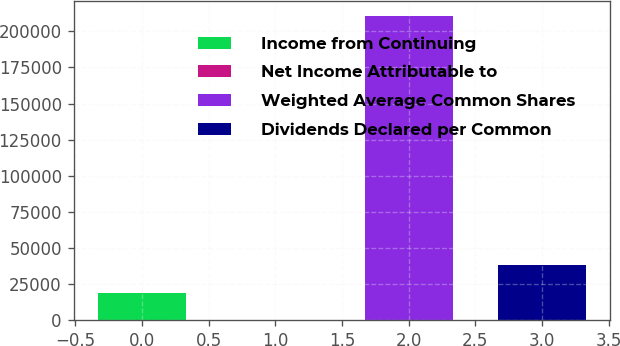<chart> <loc_0><loc_0><loc_500><loc_500><bar_chart><fcel>Income from Continuing<fcel>Net Income Attributable to<fcel>Weighted Average Common Shares<fcel>Dividends Declared per Common<nl><fcel>19241.7<fcel>0.51<fcel>210235<fcel>38482.8<nl></chart> 